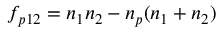Convert formula to latex. <formula><loc_0><loc_0><loc_500><loc_500>f _ { p 1 2 } = n _ { 1 } n _ { 2 } - n _ { p } ( n _ { 1 } + n _ { 2 } )</formula> 